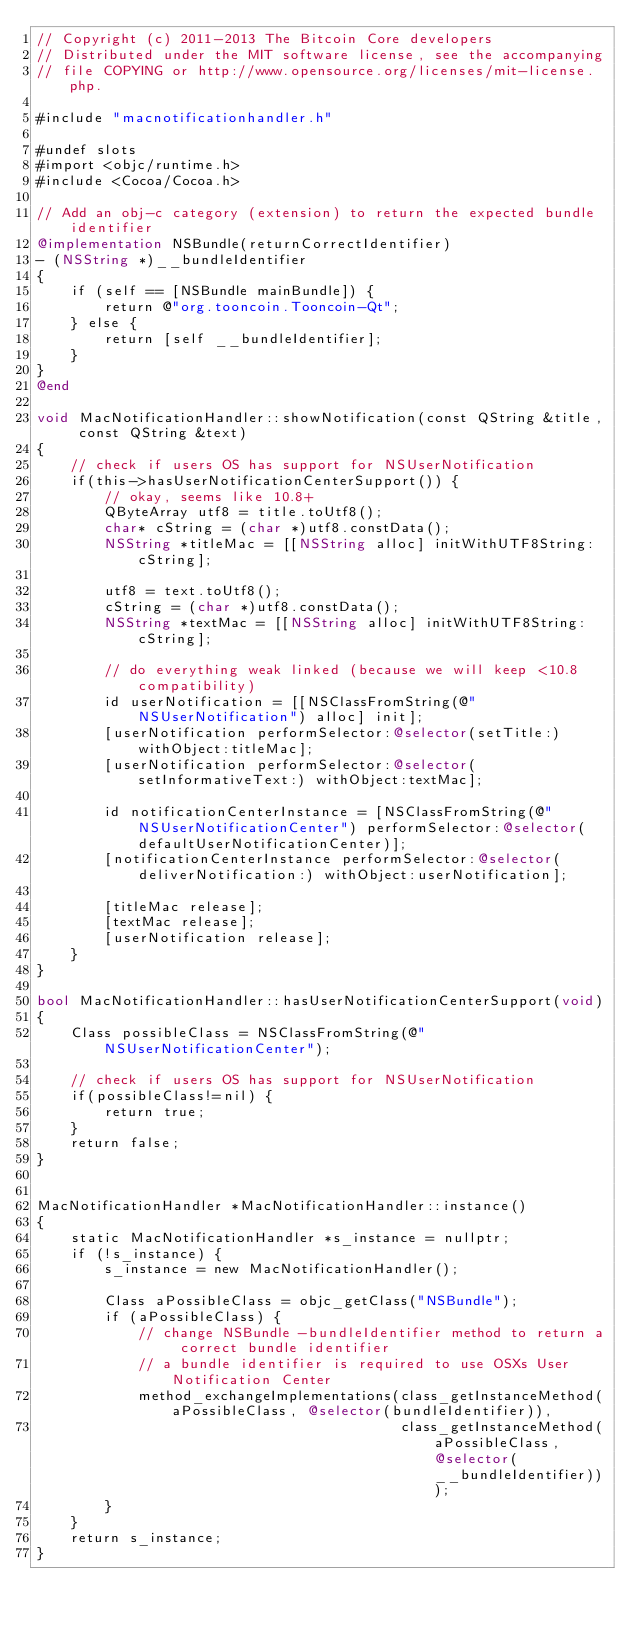<code> <loc_0><loc_0><loc_500><loc_500><_ObjectiveC_>// Copyright (c) 2011-2013 The Bitcoin Core developers
// Distributed under the MIT software license, see the accompanying
// file COPYING or http://www.opensource.org/licenses/mit-license.php.

#include "macnotificationhandler.h"

#undef slots
#import <objc/runtime.h>
#include <Cocoa/Cocoa.h>

// Add an obj-c category (extension) to return the expected bundle identifier
@implementation NSBundle(returnCorrectIdentifier)
- (NSString *)__bundleIdentifier
{
    if (self == [NSBundle mainBundle]) {
        return @"org.tooncoin.Tooncoin-Qt";
    } else {
        return [self __bundleIdentifier];
    }
}
@end

void MacNotificationHandler::showNotification(const QString &title, const QString &text)
{
    // check if users OS has support for NSUserNotification
    if(this->hasUserNotificationCenterSupport()) {
        // okay, seems like 10.8+
        QByteArray utf8 = title.toUtf8();
        char* cString = (char *)utf8.constData();
        NSString *titleMac = [[NSString alloc] initWithUTF8String:cString];

        utf8 = text.toUtf8();
        cString = (char *)utf8.constData();
        NSString *textMac = [[NSString alloc] initWithUTF8String:cString];

        // do everything weak linked (because we will keep <10.8 compatibility)
        id userNotification = [[NSClassFromString(@"NSUserNotification") alloc] init];
        [userNotification performSelector:@selector(setTitle:) withObject:titleMac];
        [userNotification performSelector:@selector(setInformativeText:) withObject:textMac];

        id notificationCenterInstance = [NSClassFromString(@"NSUserNotificationCenter") performSelector:@selector(defaultUserNotificationCenter)];
        [notificationCenterInstance performSelector:@selector(deliverNotification:) withObject:userNotification];

        [titleMac release];
        [textMac release];
        [userNotification release];
    }
}

bool MacNotificationHandler::hasUserNotificationCenterSupport(void)
{
    Class possibleClass = NSClassFromString(@"NSUserNotificationCenter");

    // check if users OS has support for NSUserNotification
    if(possibleClass!=nil) {
        return true;
    }
    return false;
}


MacNotificationHandler *MacNotificationHandler::instance()
{
    static MacNotificationHandler *s_instance = nullptr;
    if (!s_instance) {
        s_instance = new MacNotificationHandler();

        Class aPossibleClass = objc_getClass("NSBundle");
        if (aPossibleClass) {
            // change NSBundle -bundleIdentifier method to return a correct bundle identifier
            // a bundle identifier is required to use OSXs User Notification Center
            method_exchangeImplementations(class_getInstanceMethod(aPossibleClass, @selector(bundleIdentifier)),
                                           class_getInstanceMethod(aPossibleClass, @selector(__bundleIdentifier)));
        }
    }
    return s_instance;
}
</code> 